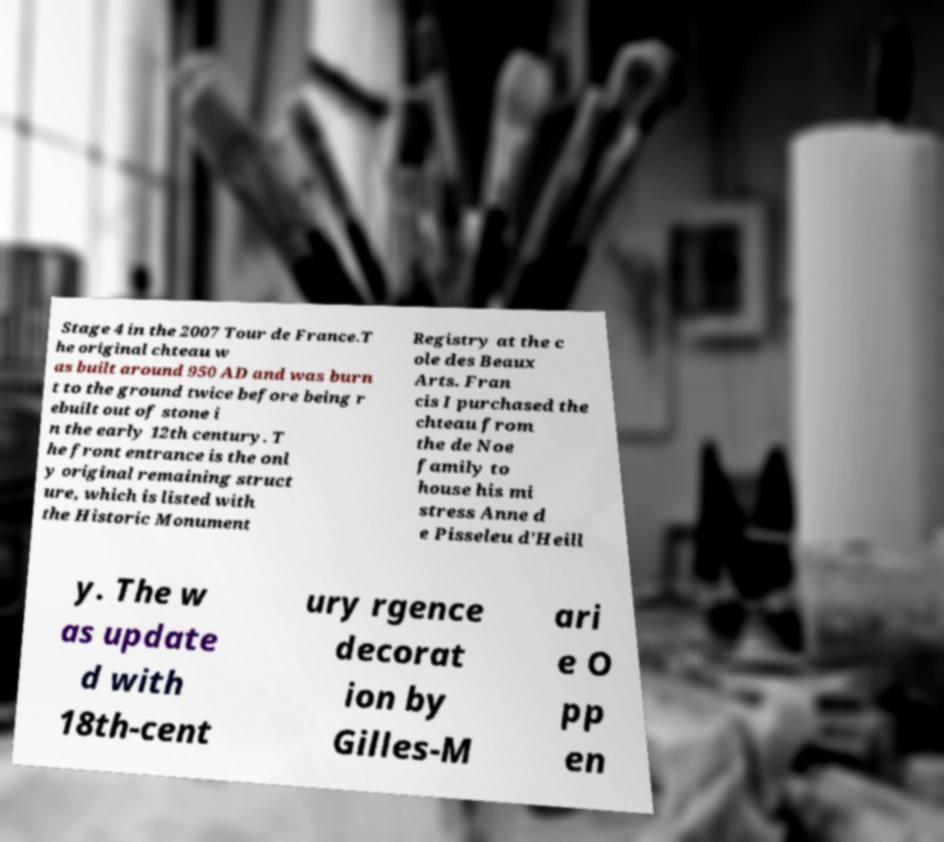For documentation purposes, I need the text within this image transcribed. Could you provide that? Stage 4 in the 2007 Tour de France.T he original chteau w as built around 950 AD and was burn t to the ground twice before being r ebuilt out of stone i n the early 12th century. T he front entrance is the onl y original remaining struct ure, which is listed with the Historic Monument Registry at the c ole des Beaux Arts. Fran cis I purchased the chteau from the de Noe family to house his mi stress Anne d e Pisseleu d'Heill y. The w as update d with 18th-cent ury rgence decorat ion by Gilles-M ari e O pp en 